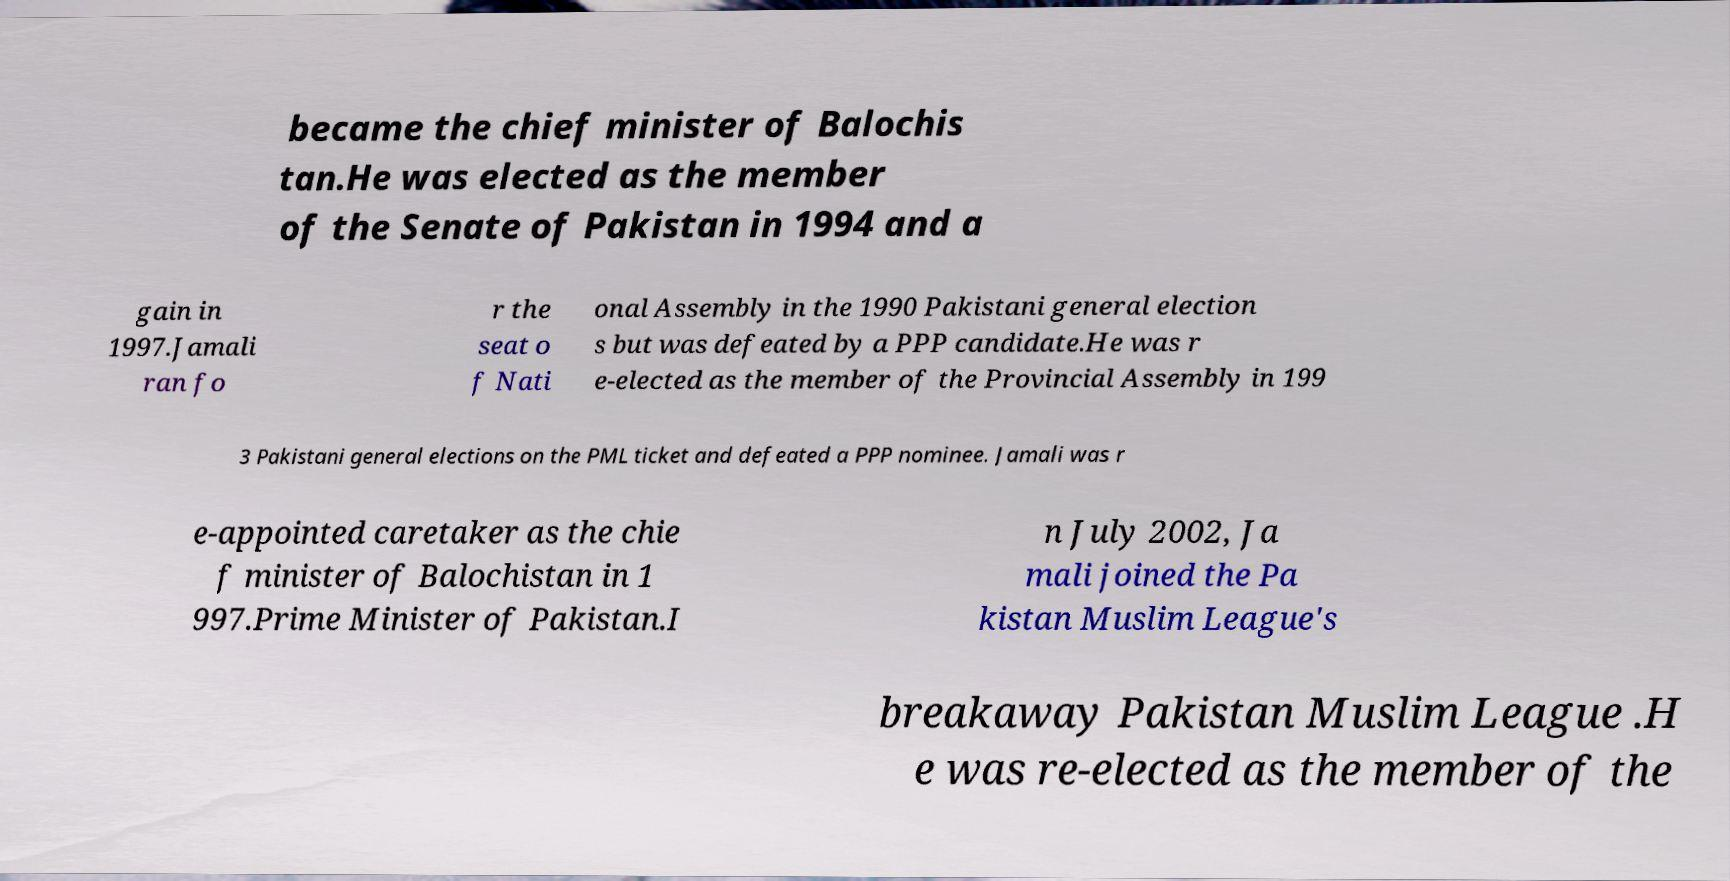Can you accurately transcribe the text from the provided image for me? became the chief minister of Balochis tan.He was elected as the member of the Senate of Pakistan in 1994 and a gain in 1997.Jamali ran fo r the seat o f Nati onal Assembly in the 1990 Pakistani general election s but was defeated by a PPP candidate.He was r e-elected as the member of the Provincial Assembly in 199 3 Pakistani general elections on the PML ticket and defeated a PPP nominee. Jamali was r e-appointed caretaker as the chie f minister of Balochistan in 1 997.Prime Minister of Pakistan.I n July 2002, Ja mali joined the Pa kistan Muslim League's breakaway Pakistan Muslim League .H e was re-elected as the member of the 